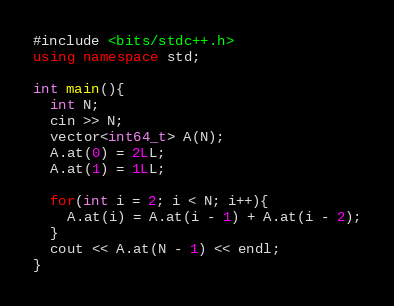Convert code to text. <code><loc_0><loc_0><loc_500><loc_500><_C++_>#include <bits/stdc++.h>
using namespace std;

int main(){
  int N;
  cin >> N;
  vector<int64_t> A(N);
  A.at(0) = 2LL;
  A.at(1) = 1LL;
  
  for(int i = 2; i < N; i++){
    A.at(i) = A.at(i - 1) + A.at(i - 2);
  }
  cout << A.at(N - 1) << endl;
}</code> 